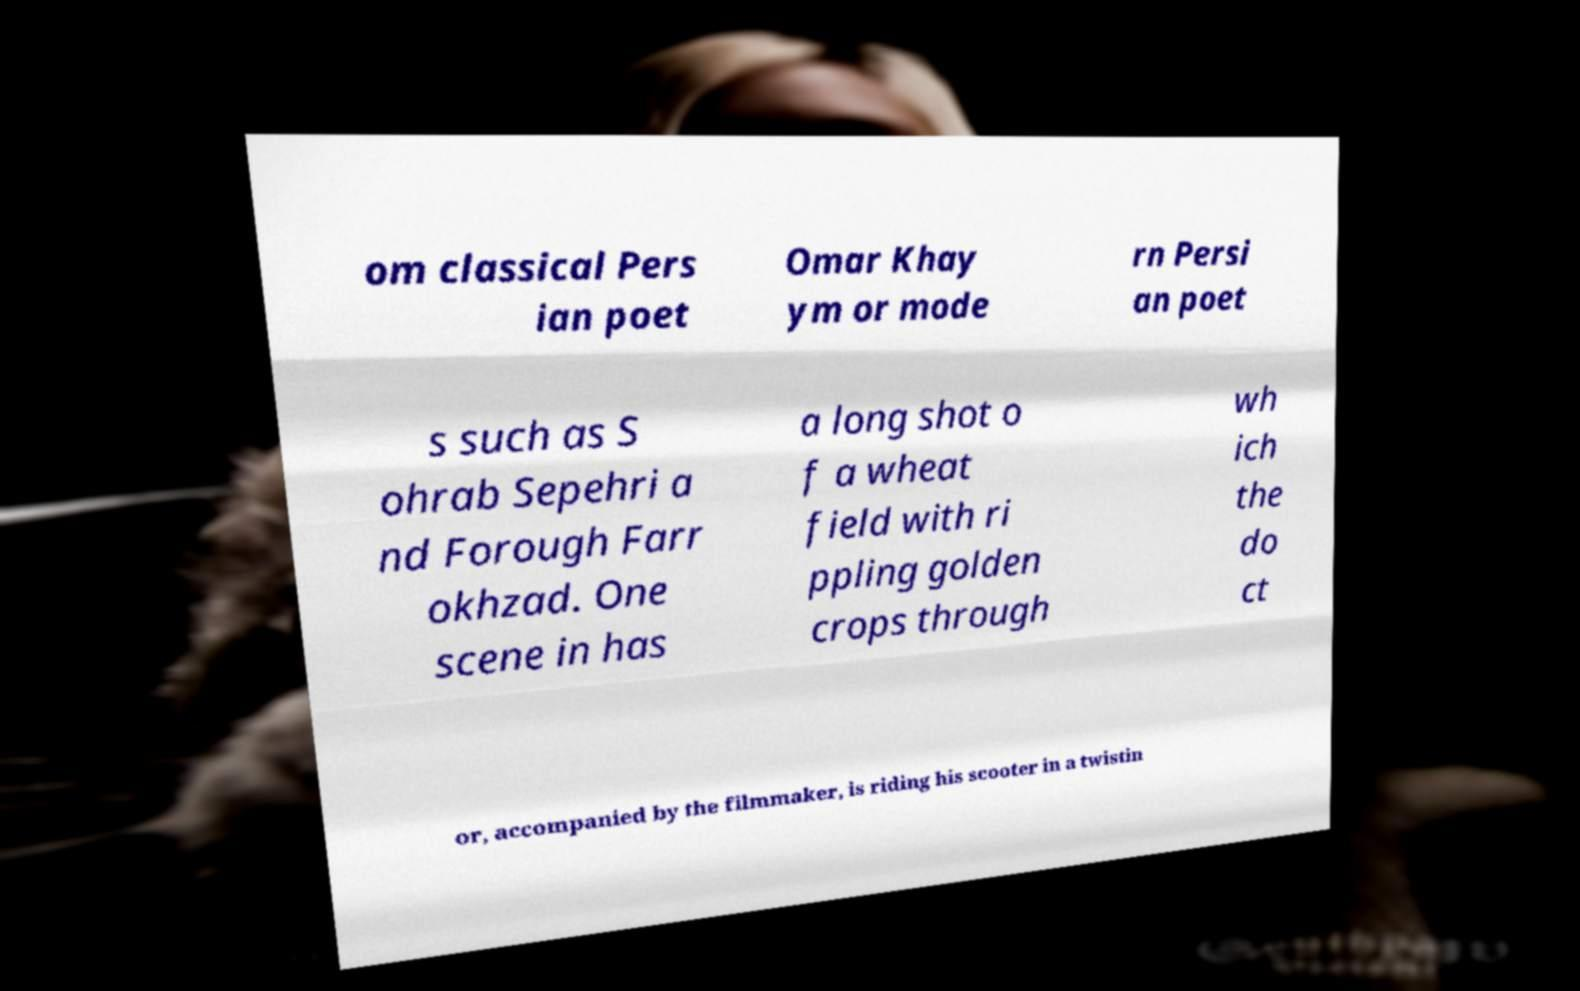I need the written content from this picture converted into text. Can you do that? om classical Pers ian poet Omar Khay ym or mode rn Persi an poet s such as S ohrab Sepehri a nd Forough Farr okhzad. One scene in has a long shot o f a wheat field with ri ppling golden crops through wh ich the do ct or, accompanied by the filmmaker, is riding his scooter in a twistin 